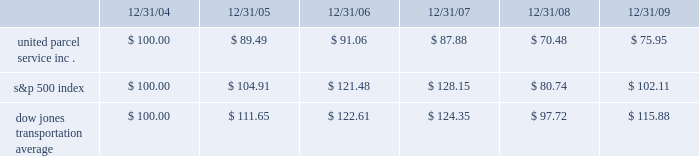( 1 ) includes shares repurchased through our publicly announced share repurchase program and shares tendered to pay the exercise price and tax withholding on employee stock options .
Shareowner return performance graph the following performance graph and related information shall not be deemed 201csoliciting material 201d or to be 201cfiled 201d with the securities and exchange commission , nor shall such information be incorporated by reference into any future filing under the securities act of 1933 or securities exchange act of 1934 , each as amended , except to the extent that the company specifically incorporates such information by reference into such filing .
The following graph shows a five-year comparison of cumulative total shareowners 2019 returns for our class b common stock , the s&p 500 index , and the dow jones transportation average .
The comparison of the total cumulative return on investment , which is the change in the quarterly stock price plus reinvested dividends for each of the quarterly periods , assumes that $ 100 was invested on december 31 , 2004 in the s&p 500 index , the dow jones transportation average , and our class b common stock .
Comparison of five year cumulative total return $ 40.00 $ 60.00 $ 80.00 $ 100.00 $ 120.00 $ 140.00 $ 160.00 2004 20092008200720062005 s&p 500 ups dj transport .

What is the roi of an investment in s&p500 in 2004 and sold in 2006? 
Computations: ((121.48 - 100) / 100)
Answer: 0.2148. ( 1 ) includes shares repurchased through our publicly announced share repurchase program and shares tendered to pay the exercise price and tax withholding on employee stock options .
Shareowner return performance graph the following performance graph and related information shall not be deemed 201csoliciting material 201d or to be 201cfiled 201d with the securities and exchange commission , nor shall such information be incorporated by reference into any future filing under the securities act of 1933 or securities exchange act of 1934 , each as amended , except to the extent that the company specifically incorporates such information by reference into such filing .
The following graph shows a five-year comparison of cumulative total shareowners 2019 returns for our class b common stock , the s&p 500 index , and the dow jones transportation average .
The comparison of the total cumulative return on investment , which is the change in the quarterly stock price plus reinvested dividends for each of the quarterly periods , assumes that $ 100 was invested on december 31 , 2004 in the s&p 500 index , the dow jones transportation average , and our class b common stock .
Comparison of five year cumulative total return $ 40.00 $ 60.00 $ 80.00 $ 100.00 $ 120.00 $ 140.00 $ 160.00 2004 20092008200720062005 s&p 500 ups dj transport .

What is the roi of an investment in ups in 2004 and sold in 2006? 
Computations: ((91.06 - 100) / 100)
Answer: -0.0894. 